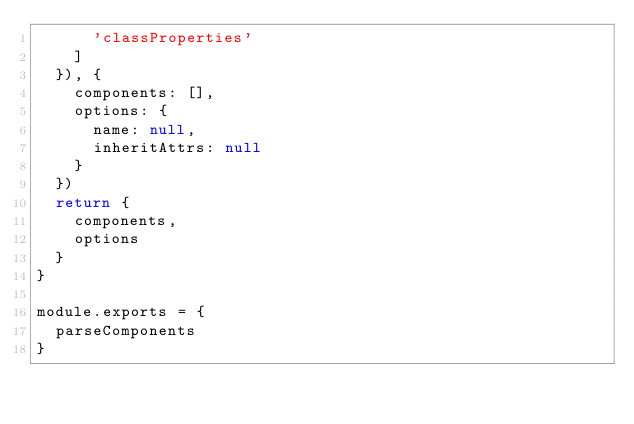Convert code to text. <code><loc_0><loc_0><loc_500><loc_500><_JavaScript_>      'classProperties'
    ]
  }), {
    components: [],
    options: {
      name: null,
      inheritAttrs: null
    }
  })
  return {
    components,
    options
  }
}

module.exports = {
  parseComponents
}
</code> 